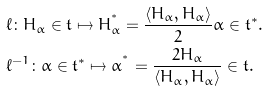<formula> <loc_0><loc_0><loc_500><loc_500>& \ell \colon H _ { \alpha } \in \mathfrak t \mapsto H _ { \alpha } ^ { ^ { * } } = \frac { \left < H _ { \alpha } , H _ { \alpha } \right > } { 2 } \alpha \in \mathfrak t ^ { * } . \\ & \ell ^ { - 1 } \colon \alpha \in \mathfrak t ^ { * } \mapsto \alpha ^ { ^ { * } } = \frac { 2 H _ { \alpha } } { \left < H _ { \alpha } , H _ { \alpha } \right > } \in \mathfrak t .</formula> 